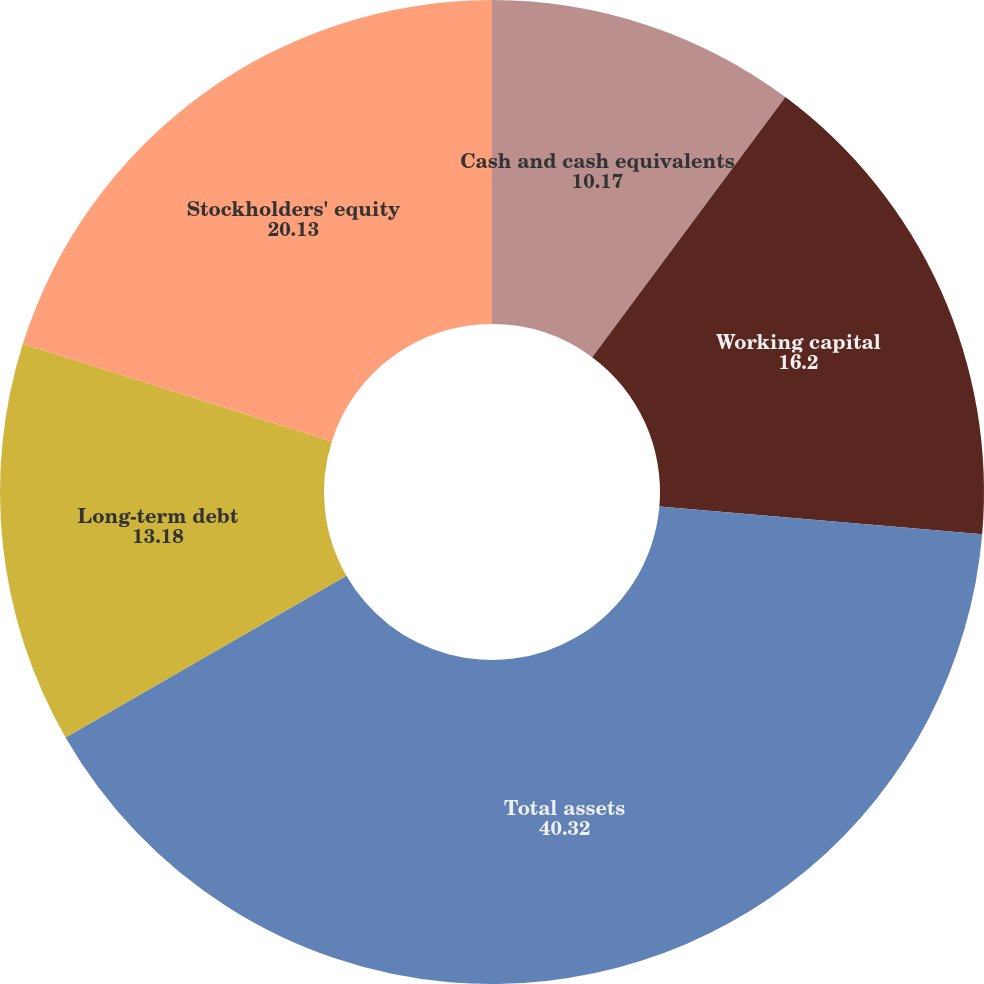Convert chart to OTSL. <chart><loc_0><loc_0><loc_500><loc_500><pie_chart><fcel>Cash and cash equivalents<fcel>Working capital<fcel>Total assets<fcel>Long-term debt<fcel>Stockholders' equity<nl><fcel>10.17%<fcel>16.2%<fcel>40.32%<fcel>13.18%<fcel>20.13%<nl></chart> 